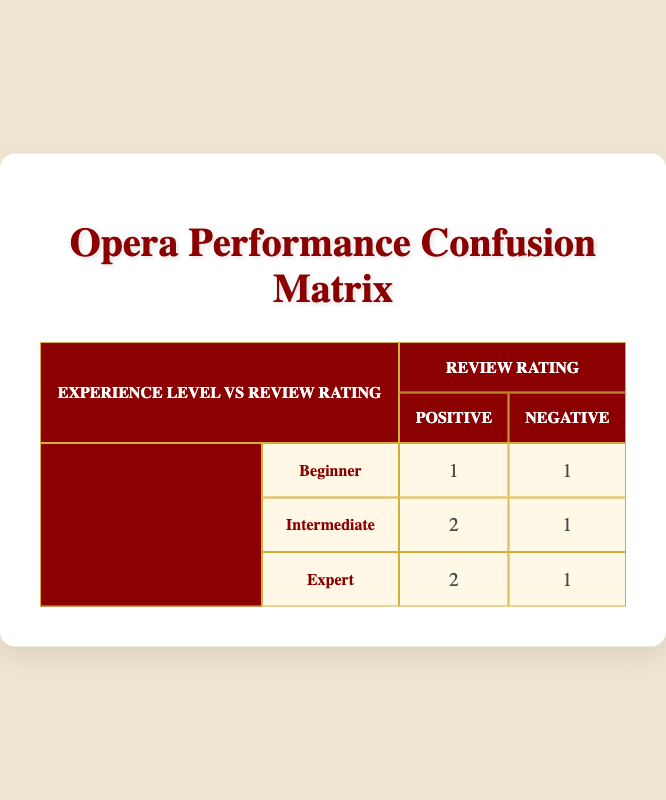What is the number of beginners who received a positive review? Looking at the table, under the "Beginner" experience level row, the value under "Positive" review rating is 1.
Answer: 1 How many intermediate cast members received a negative review? In the "Intermediate" row, the corresponding value under "Negative" review rating is 1.
Answer: 1 Is it true that all cast members with expert level experience received positive reviews? For expert level, under "Positive" the count is 2, but there is also 1 under "Negative", indicating not all received positive ratings.
Answer: No What is the total number of negative reviews across all experience levels? We sum the negative reviews: 1 (Beginner) + 1 (Intermediate) + 1 (Expert) which totals to 3.
Answer: 3 What is the ratio of positive reviews to negative reviews for intermediate cast members? For intermediate, there are 2 positive and 1 negative reviews. The ratio is 2:1.
Answer: 2:1 How many total cast members received positive reviews? We look at the positive ratings: 1 (Beginner) + 2 (Intermediate) + 2 (Expert), giving a total of 5 cast members with positive reviews.
Answer: 5 What experience level has the highest number of positive reviews? The "Intermediate" and "Expert" levels both have 2 positive ratings. Comparing all levels, they are the highest.
Answer: Intermediate and Expert How many cast members were rated in total across all experience levels? The total rows in the table indicate there are 8 performances assessed, which reflects the total cast members.
Answer: 8 Which experience level received the least positive reviews? The levels of Beginner and Intermediate both have 1 positive review each, which is the least.
Answer: Beginner and Intermediate 